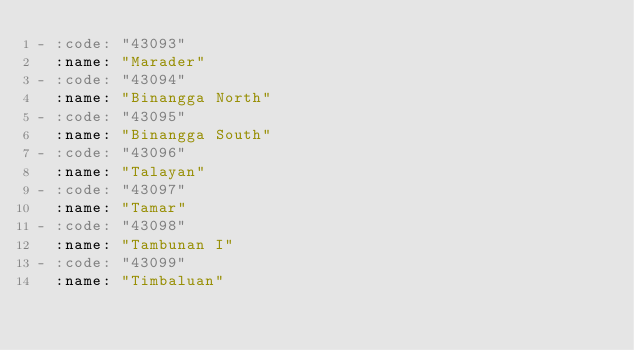<code> <loc_0><loc_0><loc_500><loc_500><_YAML_>- :code: "43093"
  :name: "Marader"
- :code: "43094"
  :name: "Binangga North"
- :code: "43095"
  :name: "Binangga South"
- :code: "43096"
  :name: "Talayan"
- :code: "43097"
  :name: "Tamar"
- :code: "43098"
  :name: "Tambunan I"
- :code: "43099"
  :name: "Timbaluan"
</code> 